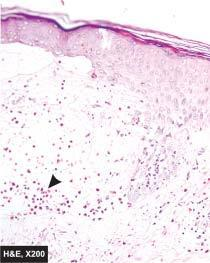what does the skin show?
Answer the question using a single word or phrase. Non-acantholytic subepidermal bulla containing microabscess of eosinophils 